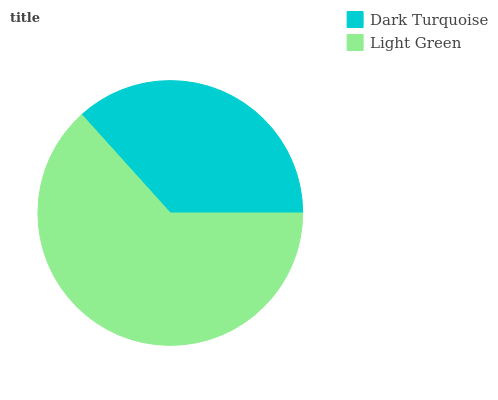Is Dark Turquoise the minimum?
Answer yes or no. Yes. Is Light Green the maximum?
Answer yes or no. Yes. Is Light Green the minimum?
Answer yes or no. No. Is Light Green greater than Dark Turquoise?
Answer yes or no. Yes. Is Dark Turquoise less than Light Green?
Answer yes or no. Yes. Is Dark Turquoise greater than Light Green?
Answer yes or no. No. Is Light Green less than Dark Turquoise?
Answer yes or no. No. Is Light Green the high median?
Answer yes or no. Yes. Is Dark Turquoise the low median?
Answer yes or no. Yes. Is Dark Turquoise the high median?
Answer yes or no. No. Is Light Green the low median?
Answer yes or no. No. 